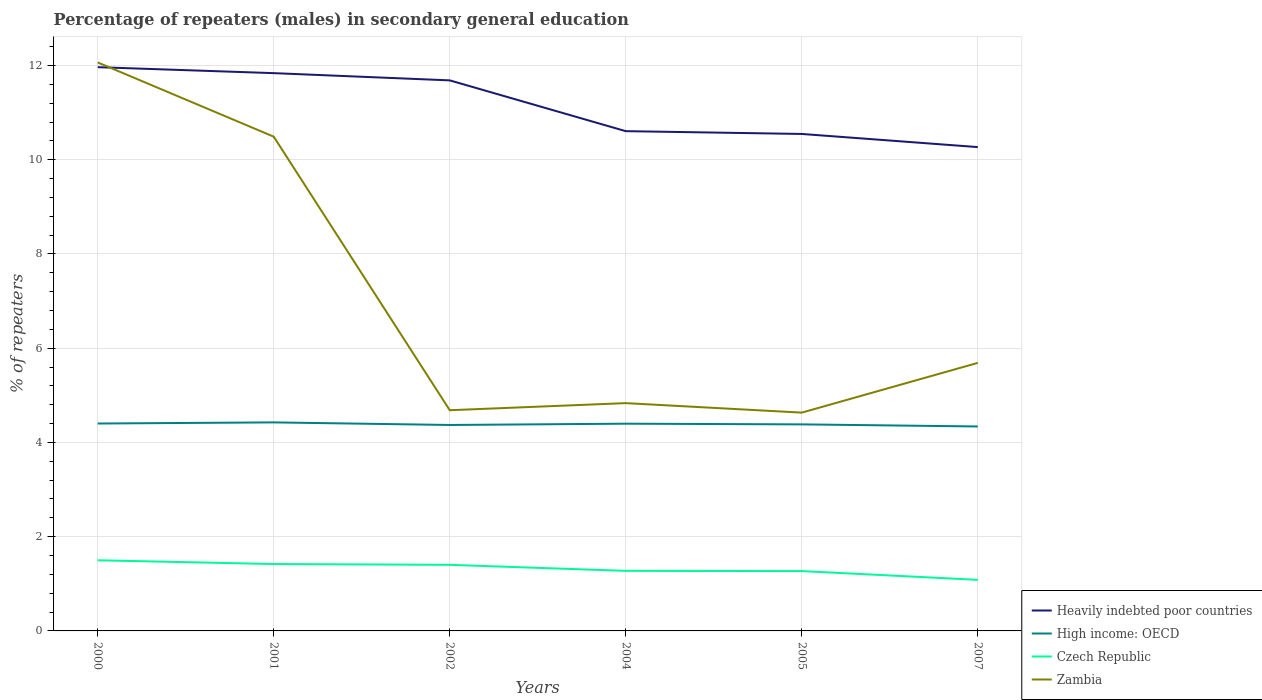Is the number of lines equal to the number of legend labels?
Provide a succinct answer. Yes. Across all years, what is the maximum percentage of male repeaters in Heavily indebted poor countries?
Provide a succinct answer. 10.27. In which year was the percentage of male repeaters in Zambia maximum?
Your answer should be very brief. 2005. What is the total percentage of male repeaters in High income: OECD in the graph?
Ensure brevity in your answer.  -0.03. What is the difference between the highest and the second highest percentage of male repeaters in Czech Republic?
Your answer should be very brief. 0.42. How many lines are there?
Ensure brevity in your answer.  4. Are the values on the major ticks of Y-axis written in scientific E-notation?
Provide a short and direct response. No. Does the graph contain any zero values?
Provide a short and direct response. No. Where does the legend appear in the graph?
Provide a succinct answer. Bottom right. How many legend labels are there?
Your answer should be compact. 4. What is the title of the graph?
Provide a succinct answer. Percentage of repeaters (males) in secondary general education. Does "Hungary" appear as one of the legend labels in the graph?
Provide a succinct answer. No. What is the label or title of the X-axis?
Your answer should be compact. Years. What is the label or title of the Y-axis?
Provide a succinct answer. % of repeaters. What is the % of repeaters of Heavily indebted poor countries in 2000?
Ensure brevity in your answer.  11.96. What is the % of repeaters in High income: OECD in 2000?
Your answer should be compact. 4.4. What is the % of repeaters of Czech Republic in 2000?
Provide a short and direct response. 1.5. What is the % of repeaters of Zambia in 2000?
Your answer should be very brief. 12.06. What is the % of repeaters of Heavily indebted poor countries in 2001?
Ensure brevity in your answer.  11.84. What is the % of repeaters of High income: OECD in 2001?
Provide a succinct answer. 4.43. What is the % of repeaters in Czech Republic in 2001?
Your answer should be compact. 1.42. What is the % of repeaters of Zambia in 2001?
Keep it short and to the point. 10.49. What is the % of repeaters of Heavily indebted poor countries in 2002?
Your response must be concise. 11.68. What is the % of repeaters of High income: OECD in 2002?
Ensure brevity in your answer.  4.37. What is the % of repeaters of Czech Republic in 2002?
Offer a very short reply. 1.4. What is the % of repeaters of Zambia in 2002?
Give a very brief answer. 4.68. What is the % of repeaters in Heavily indebted poor countries in 2004?
Keep it short and to the point. 10.61. What is the % of repeaters in High income: OECD in 2004?
Make the answer very short. 4.4. What is the % of repeaters of Czech Republic in 2004?
Give a very brief answer. 1.27. What is the % of repeaters in Zambia in 2004?
Your answer should be very brief. 4.83. What is the % of repeaters of Heavily indebted poor countries in 2005?
Your answer should be very brief. 10.55. What is the % of repeaters of High income: OECD in 2005?
Keep it short and to the point. 4.38. What is the % of repeaters in Czech Republic in 2005?
Offer a terse response. 1.27. What is the % of repeaters in Zambia in 2005?
Your answer should be compact. 4.63. What is the % of repeaters in Heavily indebted poor countries in 2007?
Provide a succinct answer. 10.27. What is the % of repeaters in High income: OECD in 2007?
Ensure brevity in your answer.  4.34. What is the % of repeaters in Czech Republic in 2007?
Your response must be concise. 1.08. What is the % of repeaters of Zambia in 2007?
Offer a very short reply. 5.69. Across all years, what is the maximum % of repeaters of Heavily indebted poor countries?
Provide a short and direct response. 11.96. Across all years, what is the maximum % of repeaters of High income: OECD?
Make the answer very short. 4.43. Across all years, what is the maximum % of repeaters in Czech Republic?
Your answer should be very brief. 1.5. Across all years, what is the maximum % of repeaters in Zambia?
Your answer should be very brief. 12.06. Across all years, what is the minimum % of repeaters of Heavily indebted poor countries?
Offer a very short reply. 10.27. Across all years, what is the minimum % of repeaters of High income: OECD?
Keep it short and to the point. 4.34. Across all years, what is the minimum % of repeaters of Czech Republic?
Your response must be concise. 1.08. Across all years, what is the minimum % of repeaters in Zambia?
Provide a short and direct response. 4.63. What is the total % of repeaters of Heavily indebted poor countries in the graph?
Keep it short and to the point. 66.91. What is the total % of repeaters in High income: OECD in the graph?
Offer a terse response. 26.32. What is the total % of repeaters in Czech Republic in the graph?
Provide a succinct answer. 7.95. What is the total % of repeaters of Zambia in the graph?
Offer a terse response. 42.39. What is the difference between the % of repeaters of Heavily indebted poor countries in 2000 and that in 2001?
Provide a succinct answer. 0.13. What is the difference between the % of repeaters of High income: OECD in 2000 and that in 2001?
Offer a very short reply. -0.02. What is the difference between the % of repeaters in Czech Republic in 2000 and that in 2001?
Offer a very short reply. 0.08. What is the difference between the % of repeaters in Zambia in 2000 and that in 2001?
Provide a short and direct response. 1.58. What is the difference between the % of repeaters in Heavily indebted poor countries in 2000 and that in 2002?
Your response must be concise. 0.28. What is the difference between the % of repeaters in High income: OECD in 2000 and that in 2002?
Your answer should be compact. 0.03. What is the difference between the % of repeaters of Czech Republic in 2000 and that in 2002?
Your answer should be very brief. 0.1. What is the difference between the % of repeaters of Zambia in 2000 and that in 2002?
Your answer should be very brief. 7.38. What is the difference between the % of repeaters of Heavily indebted poor countries in 2000 and that in 2004?
Ensure brevity in your answer.  1.36. What is the difference between the % of repeaters of High income: OECD in 2000 and that in 2004?
Keep it short and to the point. 0. What is the difference between the % of repeaters of Czech Republic in 2000 and that in 2004?
Offer a terse response. 0.22. What is the difference between the % of repeaters in Zambia in 2000 and that in 2004?
Keep it short and to the point. 7.23. What is the difference between the % of repeaters of Heavily indebted poor countries in 2000 and that in 2005?
Provide a short and direct response. 1.42. What is the difference between the % of repeaters of High income: OECD in 2000 and that in 2005?
Provide a succinct answer. 0.02. What is the difference between the % of repeaters in Czech Republic in 2000 and that in 2005?
Provide a succinct answer. 0.23. What is the difference between the % of repeaters in Zambia in 2000 and that in 2005?
Offer a very short reply. 7.43. What is the difference between the % of repeaters of Heavily indebted poor countries in 2000 and that in 2007?
Give a very brief answer. 1.7. What is the difference between the % of repeaters in High income: OECD in 2000 and that in 2007?
Your answer should be very brief. 0.06. What is the difference between the % of repeaters in Czech Republic in 2000 and that in 2007?
Provide a succinct answer. 0.42. What is the difference between the % of repeaters in Zambia in 2000 and that in 2007?
Give a very brief answer. 6.38. What is the difference between the % of repeaters of Heavily indebted poor countries in 2001 and that in 2002?
Make the answer very short. 0.15. What is the difference between the % of repeaters of High income: OECD in 2001 and that in 2002?
Keep it short and to the point. 0.05. What is the difference between the % of repeaters in Czech Republic in 2001 and that in 2002?
Your answer should be compact. 0.02. What is the difference between the % of repeaters of Zambia in 2001 and that in 2002?
Your response must be concise. 5.81. What is the difference between the % of repeaters in Heavily indebted poor countries in 2001 and that in 2004?
Offer a terse response. 1.23. What is the difference between the % of repeaters of High income: OECD in 2001 and that in 2004?
Offer a terse response. 0.03. What is the difference between the % of repeaters in Czech Republic in 2001 and that in 2004?
Offer a very short reply. 0.14. What is the difference between the % of repeaters in Zambia in 2001 and that in 2004?
Offer a terse response. 5.66. What is the difference between the % of repeaters in Heavily indebted poor countries in 2001 and that in 2005?
Provide a short and direct response. 1.29. What is the difference between the % of repeaters of High income: OECD in 2001 and that in 2005?
Your answer should be very brief. 0.04. What is the difference between the % of repeaters in Czech Republic in 2001 and that in 2005?
Give a very brief answer. 0.15. What is the difference between the % of repeaters of Zambia in 2001 and that in 2005?
Offer a very short reply. 5.86. What is the difference between the % of repeaters of Heavily indebted poor countries in 2001 and that in 2007?
Your response must be concise. 1.57. What is the difference between the % of repeaters of High income: OECD in 2001 and that in 2007?
Provide a succinct answer. 0.09. What is the difference between the % of repeaters of Czech Republic in 2001 and that in 2007?
Ensure brevity in your answer.  0.34. What is the difference between the % of repeaters in Zambia in 2001 and that in 2007?
Give a very brief answer. 4.8. What is the difference between the % of repeaters of Heavily indebted poor countries in 2002 and that in 2004?
Offer a very short reply. 1.08. What is the difference between the % of repeaters in High income: OECD in 2002 and that in 2004?
Offer a very short reply. -0.03. What is the difference between the % of repeaters of Czech Republic in 2002 and that in 2004?
Make the answer very short. 0.13. What is the difference between the % of repeaters of Zambia in 2002 and that in 2004?
Provide a succinct answer. -0.15. What is the difference between the % of repeaters of Heavily indebted poor countries in 2002 and that in 2005?
Offer a very short reply. 1.14. What is the difference between the % of repeaters in High income: OECD in 2002 and that in 2005?
Make the answer very short. -0.01. What is the difference between the % of repeaters of Czech Republic in 2002 and that in 2005?
Offer a very short reply. 0.13. What is the difference between the % of repeaters in Zambia in 2002 and that in 2005?
Your response must be concise. 0.05. What is the difference between the % of repeaters in Heavily indebted poor countries in 2002 and that in 2007?
Keep it short and to the point. 1.42. What is the difference between the % of repeaters of High income: OECD in 2002 and that in 2007?
Ensure brevity in your answer.  0.03. What is the difference between the % of repeaters in Czech Republic in 2002 and that in 2007?
Your answer should be compact. 0.32. What is the difference between the % of repeaters in Zambia in 2002 and that in 2007?
Your response must be concise. -1. What is the difference between the % of repeaters in Heavily indebted poor countries in 2004 and that in 2005?
Keep it short and to the point. 0.06. What is the difference between the % of repeaters of High income: OECD in 2004 and that in 2005?
Keep it short and to the point. 0.01. What is the difference between the % of repeaters in Czech Republic in 2004 and that in 2005?
Your answer should be compact. 0. What is the difference between the % of repeaters of Zambia in 2004 and that in 2005?
Offer a terse response. 0.2. What is the difference between the % of repeaters of Heavily indebted poor countries in 2004 and that in 2007?
Offer a very short reply. 0.34. What is the difference between the % of repeaters in High income: OECD in 2004 and that in 2007?
Provide a short and direct response. 0.06. What is the difference between the % of repeaters in Czech Republic in 2004 and that in 2007?
Make the answer very short. 0.19. What is the difference between the % of repeaters of Zambia in 2004 and that in 2007?
Provide a short and direct response. -0.85. What is the difference between the % of repeaters of Heavily indebted poor countries in 2005 and that in 2007?
Provide a short and direct response. 0.28. What is the difference between the % of repeaters in High income: OECD in 2005 and that in 2007?
Ensure brevity in your answer.  0.04. What is the difference between the % of repeaters of Czech Republic in 2005 and that in 2007?
Your answer should be compact. 0.19. What is the difference between the % of repeaters of Zambia in 2005 and that in 2007?
Your answer should be compact. -1.06. What is the difference between the % of repeaters in Heavily indebted poor countries in 2000 and the % of repeaters in High income: OECD in 2001?
Make the answer very short. 7.54. What is the difference between the % of repeaters of Heavily indebted poor countries in 2000 and the % of repeaters of Czech Republic in 2001?
Keep it short and to the point. 10.54. What is the difference between the % of repeaters in Heavily indebted poor countries in 2000 and the % of repeaters in Zambia in 2001?
Offer a terse response. 1.47. What is the difference between the % of repeaters of High income: OECD in 2000 and the % of repeaters of Czech Republic in 2001?
Provide a succinct answer. 2.98. What is the difference between the % of repeaters of High income: OECD in 2000 and the % of repeaters of Zambia in 2001?
Offer a terse response. -6.09. What is the difference between the % of repeaters in Czech Republic in 2000 and the % of repeaters in Zambia in 2001?
Give a very brief answer. -8.99. What is the difference between the % of repeaters in Heavily indebted poor countries in 2000 and the % of repeaters in High income: OECD in 2002?
Your response must be concise. 7.59. What is the difference between the % of repeaters in Heavily indebted poor countries in 2000 and the % of repeaters in Czech Republic in 2002?
Your response must be concise. 10.56. What is the difference between the % of repeaters in Heavily indebted poor countries in 2000 and the % of repeaters in Zambia in 2002?
Offer a terse response. 7.28. What is the difference between the % of repeaters of High income: OECD in 2000 and the % of repeaters of Czech Republic in 2002?
Offer a very short reply. 3. What is the difference between the % of repeaters of High income: OECD in 2000 and the % of repeaters of Zambia in 2002?
Your answer should be compact. -0.28. What is the difference between the % of repeaters of Czech Republic in 2000 and the % of repeaters of Zambia in 2002?
Your answer should be very brief. -3.19. What is the difference between the % of repeaters in Heavily indebted poor countries in 2000 and the % of repeaters in High income: OECD in 2004?
Give a very brief answer. 7.57. What is the difference between the % of repeaters of Heavily indebted poor countries in 2000 and the % of repeaters of Czech Republic in 2004?
Give a very brief answer. 10.69. What is the difference between the % of repeaters in Heavily indebted poor countries in 2000 and the % of repeaters in Zambia in 2004?
Your answer should be compact. 7.13. What is the difference between the % of repeaters in High income: OECD in 2000 and the % of repeaters in Czech Republic in 2004?
Ensure brevity in your answer.  3.13. What is the difference between the % of repeaters of High income: OECD in 2000 and the % of repeaters of Zambia in 2004?
Offer a terse response. -0.43. What is the difference between the % of repeaters in Czech Republic in 2000 and the % of repeaters in Zambia in 2004?
Make the answer very short. -3.34. What is the difference between the % of repeaters in Heavily indebted poor countries in 2000 and the % of repeaters in High income: OECD in 2005?
Make the answer very short. 7.58. What is the difference between the % of repeaters of Heavily indebted poor countries in 2000 and the % of repeaters of Czech Republic in 2005?
Your answer should be compact. 10.69. What is the difference between the % of repeaters of Heavily indebted poor countries in 2000 and the % of repeaters of Zambia in 2005?
Your answer should be compact. 7.33. What is the difference between the % of repeaters in High income: OECD in 2000 and the % of repeaters in Czech Republic in 2005?
Provide a short and direct response. 3.13. What is the difference between the % of repeaters of High income: OECD in 2000 and the % of repeaters of Zambia in 2005?
Your answer should be very brief. -0.23. What is the difference between the % of repeaters of Czech Republic in 2000 and the % of repeaters of Zambia in 2005?
Provide a short and direct response. -3.13. What is the difference between the % of repeaters in Heavily indebted poor countries in 2000 and the % of repeaters in High income: OECD in 2007?
Offer a terse response. 7.63. What is the difference between the % of repeaters in Heavily indebted poor countries in 2000 and the % of repeaters in Czech Republic in 2007?
Offer a very short reply. 10.88. What is the difference between the % of repeaters of Heavily indebted poor countries in 2000 and the % of repeaters of Zambia in 2007?
Provide a succinct answer. 6.28. What is the difference between the % of repeaters of High income: OECD in 2000 and the % of repeaters of Czech Republic in 2007?
Provide a succinct answer. 3.32. What is the difference between the % of repeaters in High income: OECD in 2000 and the % of repeaters in Zambia in 2007?
Offer a terse response. -1.29. What is the difference between the % of repeaters of Czech Republic in 2000 and the % of repeaters of Zambia in 2007?
Your answer should be very brief. -4.19. What is the difference between the % of repeaters of Heavily indebted poor countries in 2001 and the % of repeaters of High income: OECD in 2002?
Ensure brevity in your answer.  7.47. What is the difference between the % of repeaters of Heavily indebted poor countries in 2001 and the % of repeaters of Czech Republic in 2002?
Your response must be concise. 10.44. What is the difference between the % of repeaters in Heavily indebted poor countries in 2001 and the % of repeaters in Zambia in 2002?
Your answer should be very brief. 7.15. What is the difference between the % of repeaters in High income: OECD in 2001 and the % of repeaters in Czech Republic in 2002?
Provide a succinct answer. 3.02. What is the difference between the % of repeaters of High income: OECD in 2001 and the % of repeaters of Zambia in 2002?
Offer a terse response. -0.26. What is the difference between the % of repeaters of Czech Republic in 2001 and the % of repeaters of Zambia in 2002?
Offer a very short reply. -3.26. What is the difference between the % of repeaters of Heavily indebted poor countries in 2001 and the % of repeaters of High income: OECD in 2004?
Your answer should be compact. 7.44. What is the difference between the % of repeaters in Heavily indebted poor countries in 2001 and the % of repeaters in Czech Republic in 2004?
Make the answer very short. 10.56. What is the difference between the % of repeaters in Heavily indebted poor countries in 2001 and the % of repeaters in Zambia in 2004?
Your response must be concise. 7. What is the difference between the % of repeaters in High income: OECD in 2001 and the % of repeaters in Czech Republic in 2004?
Your answer should be compact. 3.15. What is the difference between the % of repeaters of High income: OECD in 2001 and the % of repeaters of Zambia in 2004?
Give a very brief answer. -0.41. What is the difference between the % of repeaters of Czech Republic in 2001 and the % of repeaters of Zambia in 2004?
Your answer should be compact. -3.42. What is the difference between the % of repeaters in Heavily indebted poor countries in 2001 and the % of repeaters in High income: OECD in 2005?
Offer a terse response. 7.45. What is the difference between the % of repeaters of Heavily indebted poor countries in 2001 and the % of repeaters of Czech Republic in 2005?
Give a very brief answer. 10.57. What is the difference between the % of repeaters in Heavily indebted poor countries in 2001 and the % of repeaters in Zambia in 2005?
Your response must be concise. 7.2. What is the difference between the % of repeaters in High income: OECD in 2001 and the % of repeaters in Czech Republic in 2005?
Provide a succinct answer. 3.16. What is the difference between the % of repeaters of High income: OECD in 2001 and the % of repeaters of Zambia in 2005?
Provide a short and direct response. -0.21. What is the difference between the % of repeaters in Czech Republic in 2001 and the % of repeaters in Zambia in 2005?
Provide a succinct answer. -3.21. What is the difference between the % of repeaters of Heavily indebted poor countries in 2001 and the % of repeaters of High income: OECD in 2007?
Keep it short and to the point. 7.5. What is the difference between the % of repeaters of Heavily indebted poor countries in 2001 and the % of repeaters of Czech Republic in 2007?
Your answer should be compact. 10.75. What is the difference between the % of repeaters in Heavily indebted poor countries in 2001 and the % of repeaters in Zambia in 2007?
Make the answer very short. 6.15. What is the difference between the % of repeaters in High income: OECD in 2001 and the % of repeaters in Czech Republic in 2007?
Provide a succinct answer. 3.34. What is the difference between the % of repeaters of High income: OECD in 2001 and the % of repeaters of Zambia in 2007?
Offer a very short reply. -1.26. What is the difference between the % of repeaters of Czech Republic in 2001 and the % of repeaters of Zambia in 2007?
Your response must be concise. -4.27. What is the difference between the % of repeaters in Heavily indebted poor countries in 2002 and the % of repeaters in High income: OECD in 2004?
Give a very brief answer. 7.29. What is the difference between the % of repeaters of Heavily indebted poor countries in 2002 and the % of repeaters of Czech Republic in 2004?
Your answer should be compact. 10.41. What is the difference between the % of repeaters in Heavily indebted poor countries in 2002 and the % of repeaters in Zambia in 2004?
Your answer should be compact. 6.85. What is the difference between the % of repeaters of High income: OECD in 2002 and the % of repeaters of Czech Republic in 2004?
Your answer should be compact. 3.1. What is the difference between the % of repeaters of High income: OECD in 2002 and the % of repeaters of Zambia in 2004?
Ensure brevity in your answer.  -0.46. What is the difference between the % of repeaters in Czech Republic in 2002 and the % of repeaters in Zambia in 2004?
Offer a very short reply. -3.43. What is the difference between the % of repeaters of Heavily indebted poor countries in 2002 and the % of repeaters of High income: OECD in 2005?
Your response must be concise. 7.3. What is the difference between the % of repeaters in Heavily indebted poor countries in 2002 and the % of repeaters in Czech Republic in 2005?
Ensure brevity in your answer.  10.41. What is the difference between the % of repeaters of Heavily indebted poor countries in 2002 and the % of repeaters of Zambia in 2005?
Make the answer very short. 7.05. What is the difference between the % of repeaters of High income: OECD in 2002 and the % of repeaters of Czech Republic in 2005?
Keep it short and to the point. 3.1. What is the difference between the % of repeaters in High income: OECD in 2002 and the % of repeaters in Zambia in 2005?
Offer a terse response. -0.26. What is the difference between the % of repeaters in Czech Republic in 2002 and the % of repeaters in Zambia in 2005?
Ensure brevity in your answer.  -3.23. What is the difference between the % of repeaters of Heavily indebted poor countries in 2002 and the % of repeaters of High income: OECD in 2007?
Your response must be concise. 7.35. What is the difference between the % of repeaters in Heavily indebted poor countries in 2002 and the % of repeaters in Czech Republic in 2007?
Your response must be concise. 10.6. What is the difference between the % of repeaters of Heavily indebted poor countries in 2002 and the % of repeaters of Zambia in 2007?
Your answer should be very brief. 6. What is the difference between the % of repeaters in High income: OECD in 2002 and the % of repeaters in Czech Republic in 2007?
Ensure brevity in your answer.  3.29. What is the difference between the % of repeaters of High income: OECD in 2002 and the % of repeaters of Zambia in 2007?
Your response must be concise. -1.32. What is the difference between the % of repeaters of Czech Republic in 2002 and the % of repeaters of Zambia in 2007?
Offer a very short reply. -4.29. What is the difference between the % of repeaters in Heavily indebted poor countries in 2004 and the % of repeaters in High income: OECD in 2005?
Give a very brief answer. 6.22. What is the difference between the % of repeaters of Heavily indebted poor countries in 2004 and the % of repeaters of Czech Republic in 2005?
Offer a terse response. 9.34. What is the difference between the % of repeaters in Heavily indebted poor countries in 2004 and the % of repeaters in Zambia in 2005?
Give a very brief answer. 5.97. What is the difference between the % of repeaters of High income: OECD in 2004 and the % of repeaters of Czech Republic in 2005?
Your answer should be compact. 3.13. What is the difference between the % of repeaters in High income: OECD in 2004 and the % of repeaters in Zambia in 2005?
Your answer should be very brief. -0.23. What is the difference between the % of repeaters of Czech Republic in 2004 and the % of repeaters of Zambia in 2005?
Your response must be concise. -3.36. What is the difference between the % of repeaters in Heavily indebted poor countries in 2004 and the % of repeaters in High income: OECD in 2007?
Make the answer very short. 6.27. What is the difference between the % of repeaters in Heavily indebted poor countries in 2004 and the % of repeaters in Czech Republic in 2007?
Offer a terse response. 9.52. What is the difference between the % of repeaters in Heavily indebted poor countries in 2004 and the % of repeaters in Zambia in 2007?
Offer a terse response. 4.92. What is the difference between the % of repeaters in High income: OECD in 2004 and the % of repeaters in Czech Republic in 2007?
Your answer should be compact. 3.31. What is the difference between the % of repeaters in High income: OECD in 2004 and the % of repeaters in Zambia in 2007?
Keep it short and to the point. -1.29. What is the difference between the % of repeaters in Czech Republic in 2004 and the % of repeaters in Zambia in 2007?
Your answer should be compact. -4.41. What is the difference between the % of repeaters in Heavily indebted poor countries in 2005 and the % of repeaters in High income: OECD in 2007?
Make the answer very short. 6.21. What is the difference between the % of repeaters in Heavily indebted poor countries in 2005 and the % of repeaters in Czech Republic in 2007?
Give a very brief answer. 9.46. What is the difference between the % of repeaters of Heavily indebted poor countries in 2005 and the % of repeaters of Zambia in 2007?
Offer a very short reply. 4.86. What is the difference between the % of repeaters in High income: OECD in 2005 and the % of repeaters in Czech Republic in 2007?
Your response must be concise. 3.3. What is the difference between the % of repeaters in High income: OECD in 2005 and the % of repeaters in Zambia in 2007?
Your answer should be compact. -1.31. What is the difference between the % of repeaters of Czech Republic in 2005 and the % of repeaters of Zambia in 2007?
Your response must be concise. -4.42. What is the average % of repeaters of Heavily indebted poor countries per year?
Your response must be concise. 11.15. What is the average % of repeaters in High income: OECD per year?
Give a very brief answer. 4.39. What is the average % of repeaters in Czech Republic per year?
Provide a short and direct response. 1.32. What is the average % of repeaters of Zambia per year?
Keep it short and to the point. 7.07. In the year 2000, what is the difference between the % of repeaters in Heavily indebted poor countries and % of repeaters in High income: OECD?
Your answer should be compact. 7.56. In the year 2000, what is the difference between the % of repeaters of Heavily indebted poor countries and % of repeaters of Czech Republic?
Make the answer very short. 10.47. In the year 2000, what is the difference between the % of repeaters of Heavily indebted poor countries and % of repeaters of Zambia?
Your answer should be compact. -0.1. In the year 2000, what is the difference between the % of repeaters in High income: OECD and % of repeaters in Czech Republic?
Your answer should be very brief. 2.9. In the year 2000, what is the difference between the % of repeaters in High income: OECD and % of repeaters in Zambia?
Provide a short and direct response. -7.66. In the year 2000, what is the difference between the % of repeaters of Czech Republic and % of repeaters of Zambia?
Your response must be concise. -10.57. In the year 2001, what is the difference between the % of repeaters of Heavily indebted poor countries and % of repeaters of High income: OECD?
Your answer should be very brief. 7.41. In the year 2001, what is the difference between the % of repeaters of Heavily indebted poor countries and % of repeaters of Czech Republic?
Offer a very short reply. 10.42. In the year 2001, what is the difference between the % of repeaters in Heavily indebted poor countries and % of repeaters in Zambia?
Your answer should be very brief. 1.35. In the year 2001, what is the difference between the % of repeaters in High income: OECD and % of repeaters in Czech Republic?
Offer a terse response. 3.01. In the year 2001, what is the difference between the % of repeaters of High income: OECD and % of repeaters of Zambia?
Offer a very short reply. -6.06. In the year 2001, what is the difference between the % of repeaters in Czech Republic and % of repeaters in Zambia?
Keep it short and to the point. -9.07. In the year 2002, what is the difference between the % of repeaters of Heavily indebted poor countries and % of repeaters of High income: OECD?
Offer a terse response. 7.31. In the year 2002, what is the difference between the % of repeaters of Heavily indebted poor countries and % of repeaters of Czech Republic?
Make the answer very short. 10.28. In the year 2002, what is the difference between the % of repeaters of Heavily indebted poor countries and % of repeaters of Zambia?
Keep it short and to the point. 7. In the year 2002, what is the difference between the % of repeaters of High income: OECD and % of repeaters of Czech Republic?
Your response must be concise. 2.97. In the year 2002, what is the difference between the % of repeaters of High income: OECD and % of repeaters of Zambia?
Your answer should be very brief. -0.31. In the year 2002, what is the difference between the % of repeaters of Czech Republic and % of repeaters of Zambia?
Offer a very short reply. -3.28. In the year 2004, what is the difference between the % of repeaters of Heavily indebted poor countries and % of repeaters of High income: OECD?
Your answer should be compact. 6.21. In the year 2004, what is the difference between the % of repeaters of Heavily indebted poor countries and % of repeaters of Czech Republic?
Ensure brevity in your answer.  9.33. In the year 2004, what is the difference between the % of repeaters of Heavily indebted poor countries and % of repeaters of Zambia?
Your answer should be compact. 5.77. In the year 2004, what is the difference between the % of repeaters of High income: OECD and % of repeaters of Czech Republic?
Provide a succinct answer. 3.12. In the year 2004, what is the difference between the % of repeaters in High income: OECD and % of repeaters in Zambia?
Offer a terse response. -0.44. In the year 2004, what is the difference between the % of repeaters in Czech Republic and % of repeaters in Zambia?
Offer a very short reply. -3.56. In the year 2005, what is the difference between the % of repeaters in Heavily indebted poor countries and % of repeaters in High income: OECD?
Give a very brief answer. 6.16. In the year 2005, what is the difference between the % of repeaters in Heavily indebted poor countries and % of repeaters in Czech Republic?
Keep it short and to the point. 9.28. In the year 2005, what is the difference between the % of repeaters in Heavily indebted poor countries and % of repeaters in Zambia?
Your answer should be compact. 5.91. In the year 2005, what is the difference between the % of repeaters in High income: OECD and % of repeaters in Czech Republic?
Ensure brevity in your answer.  3.11. In the year 2005, what is the difference between the % of repeaters of High income: OECD and % of repeaters of Zambia?
Provide a short and direct response. -0.25. In the year 2005, what is the difference between the % of repeaters in Czech Republic and % of repeaters in Zambia?
Your answer should be very brief. -3.36. In the year 2007, what is the difference between the % of repeaters in Heavily indebted poor countries and % of repeaters in High income: OECD?
Ensure brevity in your answer.  5.93. In the year 2007, what is the difference between the % of repeaters of Heavily indebted poor countries and % of repeaters of Czech Republic?
Ensure brevity in your answer.  9.18. In the year 2007, what is the difference between the % of repeaters in Heavily indebted poor countries and % of repeaters in Zambia?
Keep it short and to the point. 4.58. In the year 2007, what is the difference between the % of repeaters in High income: OECD and % of repeaters in Czech Republic?
Your response must be concise. 3.26. In the year 2007, what is the difference between the % of repeaters in High income: OECD and % of repeaters in Zambia?
Your response must be concise. -1.35. In the year 2007, what is the difference between the % of repeaters of Czech Republic and % of repeaters of Zambia?
Your answer should be very brief. -4.6. What is the ratio of the % of repeaters in Heavily indebted poor countries in 2000 to that in 2001?
Give a very brief answer. 1.01. What is the ratio of the % of repeaters in Czech Republic in 2000 to that in 2001?
Offer a very short reply. 1.06. What is the ratio of the % of repeaters in Zambia in 2000 to that in 2001?
Give a very brief answer. 1.15. What is the ratio of the % of repeaters in Heavily indebted poor countries in 2000 to that in 2002?
Keep it short and to the point. 1.02. What is the ratio of the % of repeaters in High income: OECD in 2000 to that in 2002?
Keep it short and to the point. 1.01. What is the ratio of the % of repeaters in Czech Republic in 2000 to that in 2002?
Your answer should be compact. 1.07. What is the ratio of the % of repeaters of Zambia in 2000 to that in 2002?
Your response must be concise. 2.58. What is the ratio of the % of repeaters of Heavily indebted poor countries in 2000 to that in 2004?
Provide a succinct answer. 1.13. What is the ratio of the % of repeaters in High income: OECD in 2000 to that in 2004?
Keep it short and to the point. 1. What is the ratio of the % of repeaters in Czech Republic in 2000 to that in 2004?
Your answer should be compact. 1.18. What is the ratio of the % of repeaters of Zambia in 2000 to that in 2004?
Your answer should be very brief. 2.5. What is the ratio of the % of repeaters of Heavily indebted poor countries in 2000 to that in 2005?
Provide a short and direct response. 1.13. What is the ratio of the % of repeaters of Czech Republic in 2000 to that in 2005?
Your answer should be compact. 1.18. What is the ratio of the % of repeaters in Zambia in 2000 to that in 2005?
Keep it short and to the point. 2.6. What is the ratio of the % of repeaters in Heavily indebted poor countries in 2000 to that in 2007?
Offer a terse response. 1.17. What is the ratio of the % of repeaters of High income: OECD in 2000 to that in 2007?
Offer a terse response. 1.01. What is the ratio of the % of repeaters in Czech Republic in 2000 to that in 2007?
Offer a terse response. 1.38. What is the ratio of the % of repeaters of Zambia in 2000 to that in 2007?
Provide a succinct answer. 2.12. What is the ratio of the % of repeaters of Heavily indebted poor countries in 2001 to that in 2002?
Provide a short and direct response. 1.01. What is the ratio of the % of repeaters of High income: OECD in 2001 to that in 2002?
Make the answer very short. 1.01. What is the ratio of the % of repeaters of Zambia in 2001 to that in 2002?
Keep it short and to the point. 2.24. What is the ratio of the % of repeaters of Heavily indebted poor countries in 2001 to that in 2004?
Give a very brief answer. 1.12. What is the ratio of the % of repeaters in High income: OECD in 2001 to that in 2004?
Your answer should be very brief. 1.01. What is the ratio of the % of repeaters in Czech Republic in 2001 to that in 2004?
Offer a very short reply. 1.11. What is the ratio of the % of repeaters in Zambia in 2001 to that in 2004?
Offer a very short reply. 2.17. What is the ratio of the % of repeaters in Heavily indebted poor countries in 2001 to that in 2005?
Your answer should be compact. 1.12. What is the ratio of the % of repeaters of High income: OECD in 2001 to that in 2005?
Give a very brief answer. 1.01. What is the ratio of the % of repeaters of Czech Republic in 2001 to that in 2005?
Make the answer very short. 1.12. What is the ratio of the % of repeaters in Zambia in 2001 to that in 2005?
Offer a very short reply. 2.26. What is the ratio of the % of repeaters of Heavily indebted poor countries in 2001 to that in 2007?
Make the answer very short. 1.15. What is the ratio of the % of repeaters of Czech Republic in 2001 to that in 2007?
Your response must be concise. 1.31. What is the ratio of the % of repeaters of Zambia in 2001 to that in 2007?
Give a very brief answer. 1.84. What is the ratio of the % of repeaters of Heavily indebted poor countries in 2002 to that in 2004?
Keep it short and to the point. 1.1. What is the ratio of the % of repeaters of Czech Republic in 2002 to that in 2004?
Provide a succinct answer. 1.1. What is the ratio of the % of repeaters in Zambia in 2002 to that in 2004?
Your answer should be very brief. 0.97. What is the ratio of the % of repeaters of Heavily indebted poor countries in 2002 to that in 2005?
Your response must be concise. 1.11. What is the ratio of the % of repeaters in High income: OECD in 2002 to that in 2005?
Provide a succinct answer. 1. What is the ratio of the % of repeaters in Czech Republic in 2002 to that in 2005?
Give a very brief answer. 1.1. What is the ratio of the % of repeaters of Heavily indebted poor countries in 2002 to that in 2007?
Your answer should be compact. 1.14. What is the ratio of the % of repeaters of High income: OECD in 2002 to that in 2007?
Keep it short and to the point. 1.01. What is the ratio of the % of repeaters in Czech Republic in 2002 to that in 2007?
Offer a very short reply. 1.29. What is the ratio of the % of repeaters in Zambia in 2002 to that in 2007?
Make the answer very short. 0.82. What is the ratio of the % of repeaters of Heavily indebted poor countries in 2004 to that in 2005?
Make the answer very short. 1.01. What is the ratio of the % of repeaters in High income: OECD in 2004 to that in 2005?
Your answer should be very brief. 1. What is the ratio of the % of repeaters in Zambia in 2004 to that in 2005?
Your answer should be compact. 1.04. What is the ratio of the % of repeaters of Heavily indebted poor countries in 2004 to that in 2007?
Offer a very short reply. 1.03. What is the ratio of the % of repeaters in High income: OECD in 2004 to that in 2007?
Provide a succinct answer. 1.01. What is the ratio of the % of repeaters in Czech Republic in 2004 to that in 2007?
Offer a terse response. 1.18. What is the ratio of the % of repeaters in Zambia in 2004 to that in 2007?
Offer a terse response. 0.85. What is the ratio of the % of repeaters in Heavily indebted poor countries in 2005 to that in 2007?
Ensure brevity in your answer.  1.03. What is the ratio of the % of repeaters in High income: OECD in 2005 to that in 2007?
Offer a very short reply. 1.01. What is the ratio of the % of repeaters of Czech Republic in 2005 to that in 2007?
Your answer should be very brief. 1.17. What is the ratio of the % of repeaters in Zambia in 2005 to that in 2007?
Your answer should be compact. 0.81. What is the difference between the highest and the second highest % of repeaters in Heavily indebted poor countries?
Make the answer very short. 0.13. What is the difference between the highest and the second highest % of repeaters of High income: OECD?
Your answer should be very brief. 0.02. What is the difference between the highest and the second highest % of repeaters of Czech Republic?
Provide a short and direct response. 0.08. What is the difference between the highest and the second highest % of repeaters of Zambia?
Your answer should be compact. 1.58. What is the difference between the highest and the lowest % of repeaters of Heavily indebted poor countries?
Make the answer very short. 1.7. What is the difference between the highest and the lowest % of repeaters of High income: OECD?
Your answer should be compact. 0.09. What is the difference between the highest and the lowest % of repeaters of Czech Republic?
Your answer should be very brief. 0.42. What is the difference between the highest and the lowest % of repeaters in Zambia?
Your answer should be very brief. 7.43. 